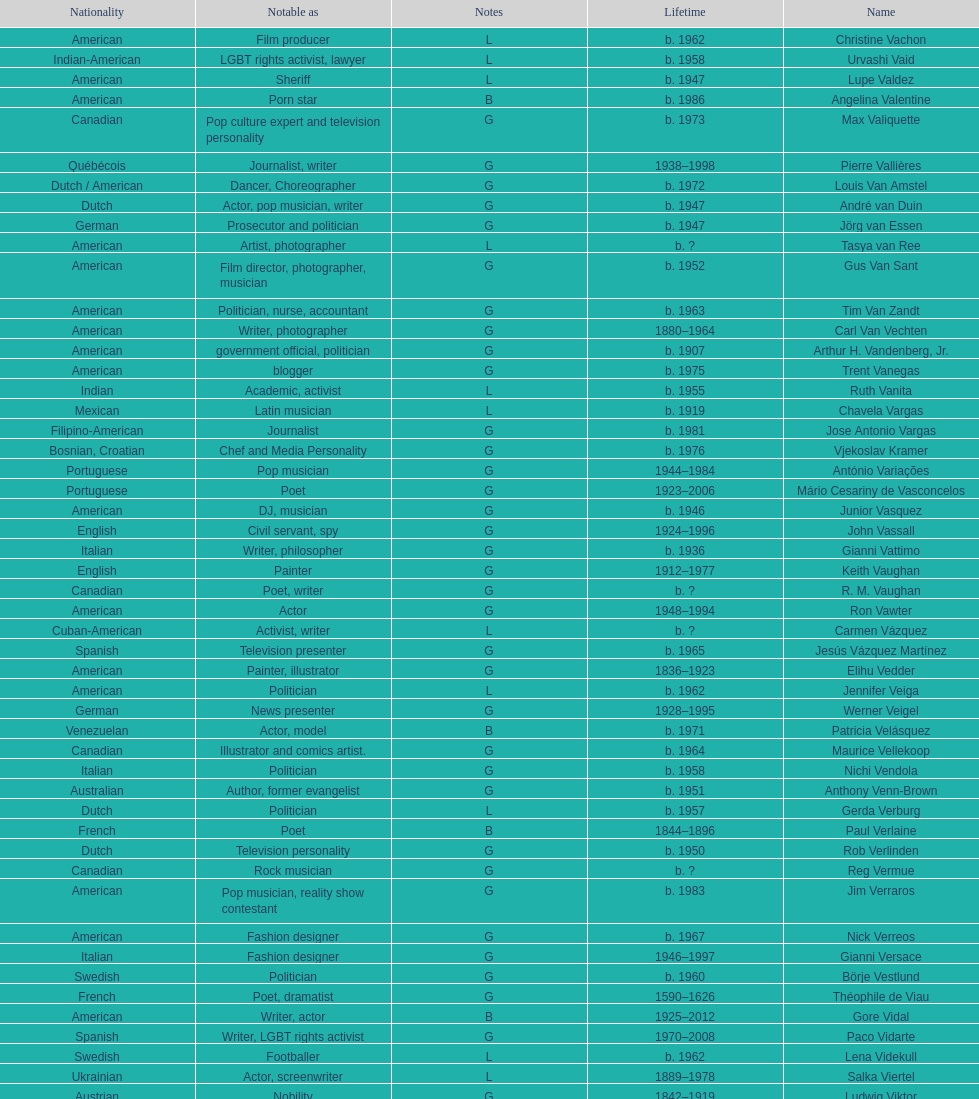Which is the previous name from lupe valdez Urvashi Vaid. 